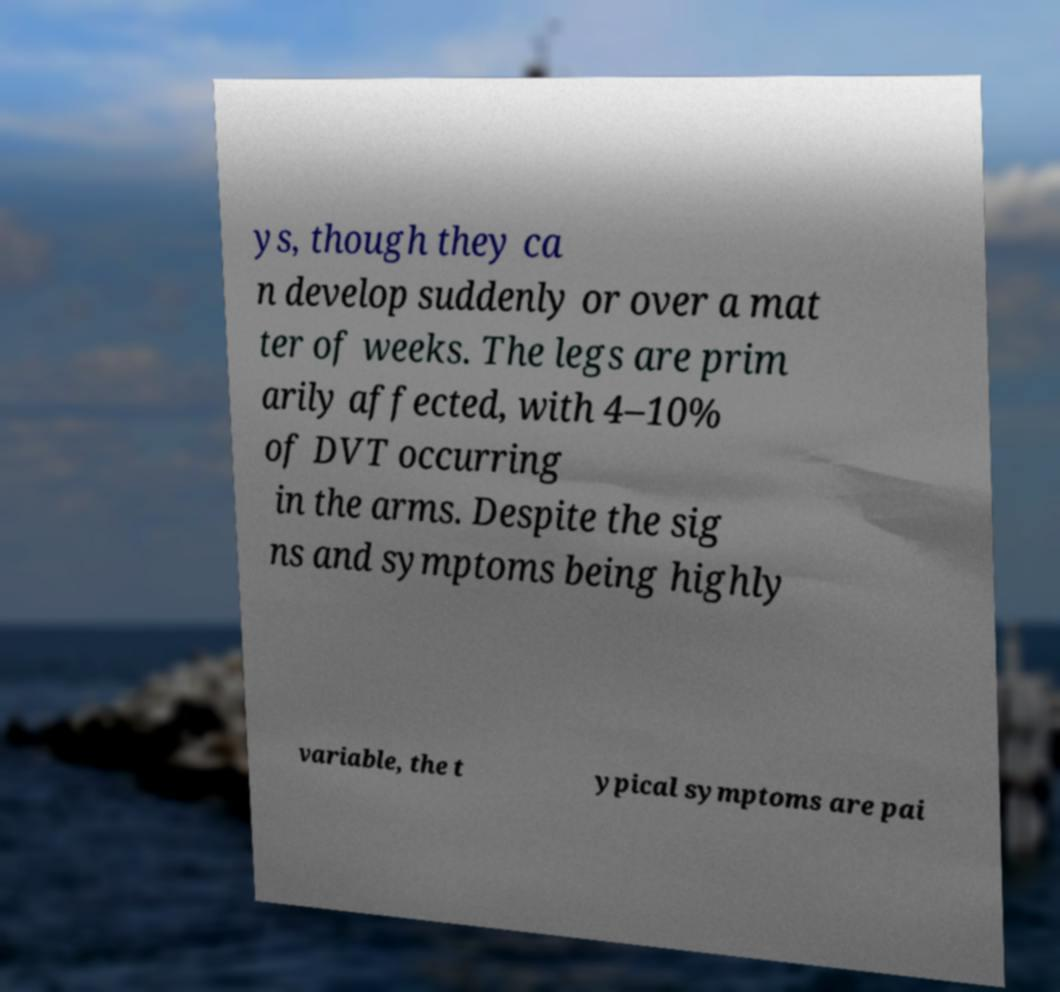Can you accurately transcribe the text from the provided image for me? ys, though they ca n develop suddenly or over a mat ter of weeks. The legs are prim arily affected, with 4–10% of DVT occurring in the arms. Despite the sig ns and symptoms being highly variable, the t ypical symptoms are pai 